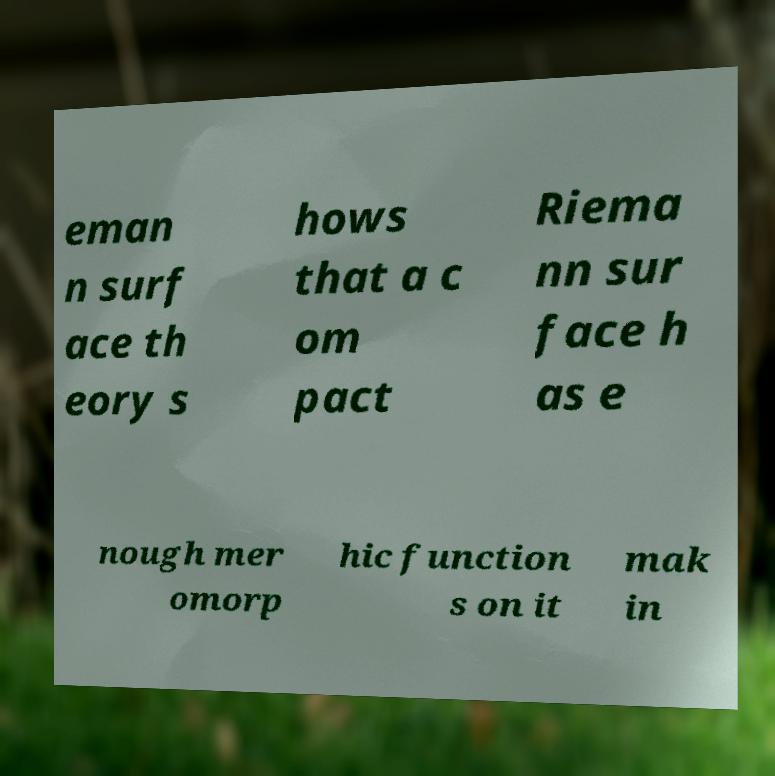Could you extract and type out the text from this image? eman n surf ace th eory s hows that a c om pact Riema nn sur face h as e nough mer omorp hic function s on it mak in 